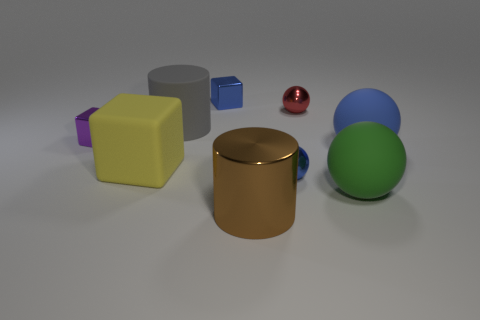Subtract all tiny blue shiny balls. How many balls are left? 3 Subtract 2 blocks. How many blocks are left? 1 Subtract all yellow blocks. How many blocks are left? 2 Subtract all spheres. How many objects are left? 5 Subtract all red balls. Subtract all gray cylinders. How many balls are left? 3 Subtract all yellow balls. How many yellow cubes are left? 1 Subtract all gray matte cylinders. Subtract all large brown things. How many objects are left? 7 Add 6 red objects. How many red objects are left? 7 Add 1 small blue spheres. How many small blue spheres exist? 2 Subtract 1 yellow blocks. How many objects are left? 8 